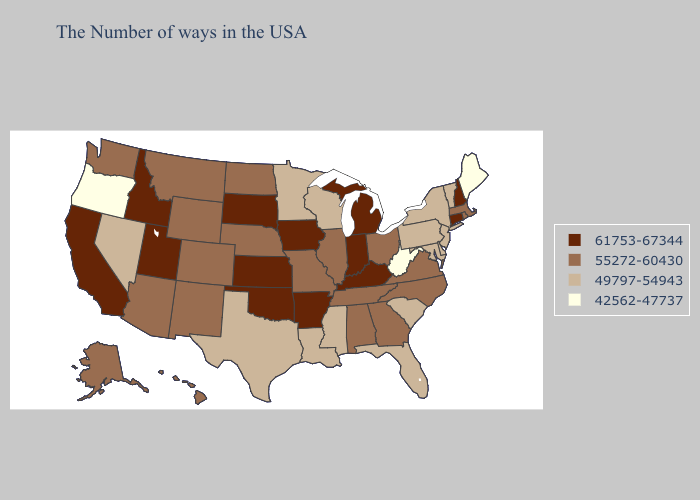Name the states that have a value in the range 42562-47737?
Concise answer only. Maine, West Virginia, Oregon. Name the states that have a value in the range 55272-60430?
Answer briefly. Massachusetts, Rhode Island, Virginia, North Carolina, Ohio, Georgia, Alabama, Tennessee, Illinois, Missouri, Nebraska, North Dakota, Wyoming, Colorado, New Mexico, Montana, Arizona, Washington, Alaska, Hawaii. Name the states that have a value in the range 55272-60430?
Be succinct. Massachusetts, Rhode Island, Virginia, North Carolina, Ohio, Georgia, Alabama, Tennessee, Illinois, Missouri, Nebraska, North Dakota, Wyoming, Colorado, New Mexico, Montana, Arizona, Washington, Alaska, Hawaii. Among the states that border Mississippi , which have the highest value?
Quick response, please. Arkansas. How many symbols are there in the legend?
Quick response, please. 4. Does the first symbol in the legend represent the smallest category?
Write a very short answer. No. Name the states that have a value in the range 61753-67344?
Give a very brief answer. New Hampshire, Connecticut, Michigan, Kentucky, Indiana, Arkansas, Iowa, Kansas, Oklahoma, South Dakota, Utah, Idaho, California. Does the map have missing data?
Keep it brief. No. Among the states that border California , which have the highest value?
Be succinct. Arizona. Which states have the lowest value in the USA?
Keep it brief. Maine, West Virginia, Oregon. What is the value of North Dakota?
Keep it brief. 55272-60430. Which states have the highest value in the USA?
Write a very short answer. New Hampshire, Connecticut, Michigan, Kentucky, Indiana, Arkansas, Iowa, Kansas, Oklahoma, South Dakota, Utah, Idaho, California. Does Iowa have the highest value in the USA?
Quick response, please. Yes. What is the highest value in states that border North Dakota?
Keep it brief. 61753-67344. Name the states that have a value in the range 42562-47737?
Short answer required. Maine, West Virginia, Oregon. 